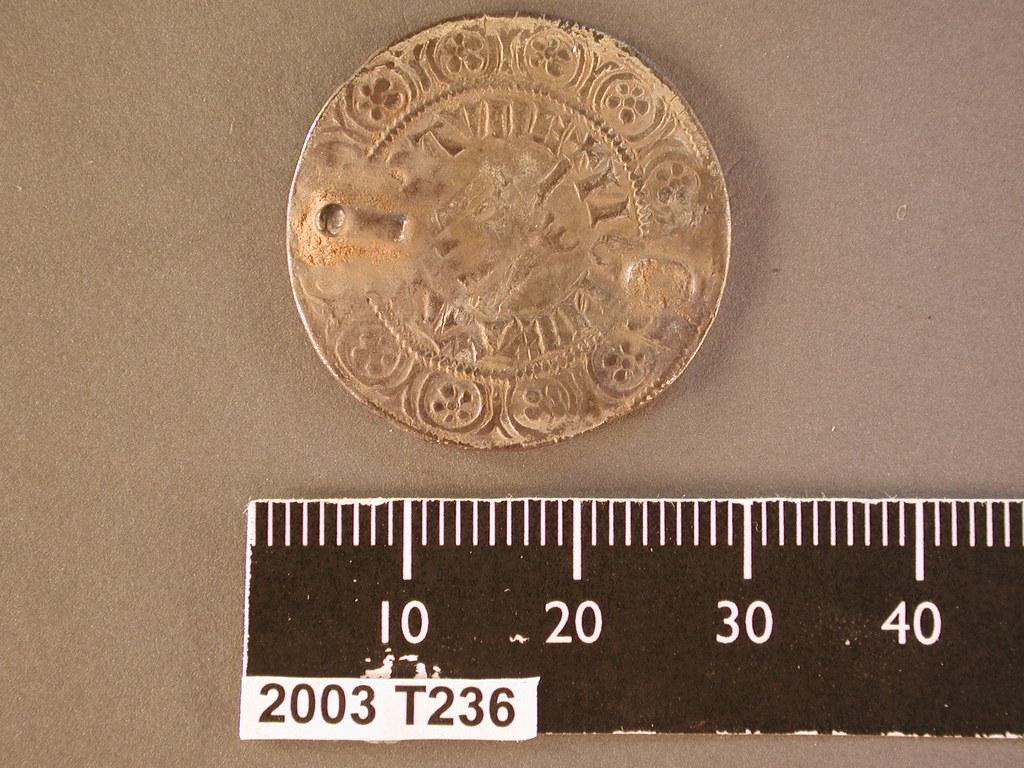<image>
Present a compact description of the photo's key features. A golden coin next to ruler with the number 2003 printed on it 